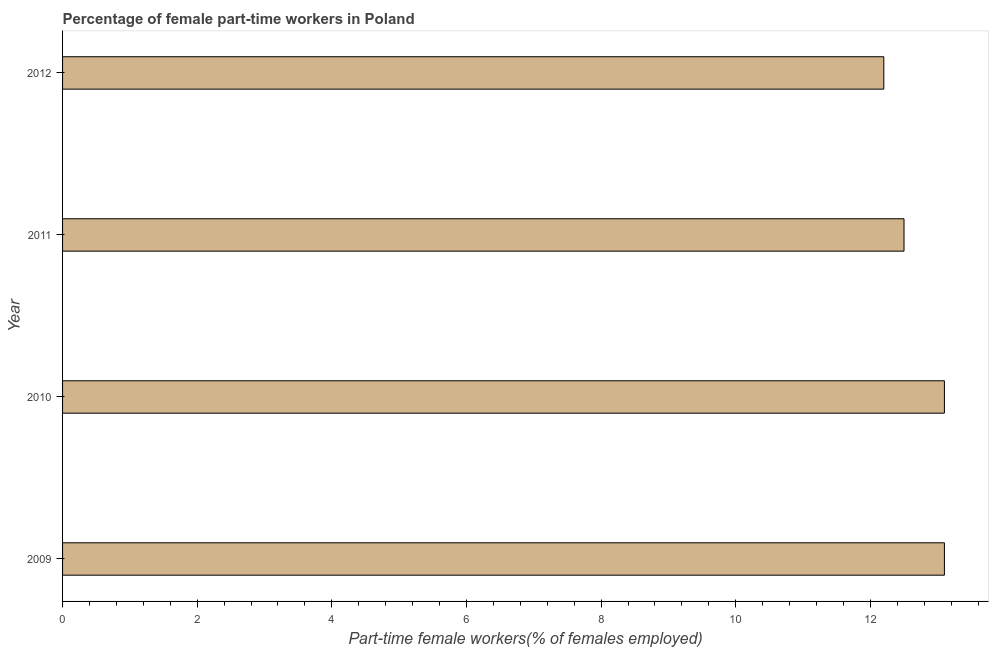Does the graph contain any zero values?
Keep it short and to the point. No. What is the title of the graph?
Make the answer very short. Percentage of female part-time workers in Poland. What is the label or title of the X-axis?
Provide a short and direct response. Part-time female workers(% of females employed). What is the percentage of part-time female workers in 2010?
Your answer should be very brief. 13.1. Across all years, what is the maximum percentage of part-time female workers?
Your answer should be very brief. 13.1. Across all years, what is the minimum percentage of part-time female workers?
Offer a very short reply. 12.2. In which year was the percentage of part-time female workers maximum?
Your answer should be very brief. 2009. What is the sum of the percentage of part-time female workers?
Provide a short and direct response. 50.9. What is the difference between the percentage of part-time female workers in 2009 and 2012?
Provide a short and direct response. 0.9. What is the average percentage of part-time female workers per year?
Offer a terse response. 12.72. What is the median percentage of part-time female workers?
Offer a terse response. 12.8. Do a majority of the years between 2009 and 2010 (inclusive) have percentage of part-time female workers greater than 13.2 %?
Offer a terse response. No. What is the ratio of the percentage of part-time female workers in 2010 to that in 2011?
Offer a terse response. 1.05. What is the difference between the highest and the second highest percentage of part-time female workers?
Provide a succinct answer. 0. Is the sum of the percentage of part-time female workers in 2009 and 2012 greater than the maximum percentage of part-time female workers across all years?
Your response must be concise. Yes. In how many years, is the percentage of part-time female workers greater than the average percentage of part-time female workers taken over all years?
Provide a succinct answer. 2. How many bars are there?
Your answer should be very brief. 4. How many years are there in the graph?
Your answer should be compact. 4. What is the Part-time female workers(% of females employed) in 2009?
Your response must be concise. 13.1. What is the Part-time female workers(% of females employed) of 2010?
Provide a succinct answer. 13.1. What is the Part-time female workers(% of females employed) in 2011?
Your answer should be very brief. 12.5. What is the Part-time female workers(% of females employed) of 2012?
Offer a terse response. 12.2. What is the difference between the Part-time female workers(% of females employed) in 2009 and 2010?
Your answer should be very brief. 0. What is the difference between the Part-time female workers(% of females employed) in 2009 and 2011?
Make the answer very short. 0.6. What is the difference between the Part-time female workers(% of females employed) in 2010 and 2012?
Provide a short and direct response. 0.9. What is the ratio of the Part-time female workers(% of females employed) in 2009 to that in 2011?
Keep it short and to the point. 1.05. What is the ratio of the Part-time female workers(% of females employed) in 2009 to that in 2012?
Keep it short and to the point. 1.07. What is the ratio of the Part-time female workers(% of females employed) in 2010 to that in 2011?
Ensure brevity in your answer.  1.05. What is the ratio of the Part-time female workers(% of females employed) in 2010 to that in 2012?
Offer a very short reply. 1.07. What is the ratio of the Part-time female workers(% of females employed) in 2011 to that in 2012?
Make the answer very short. 1.02. 